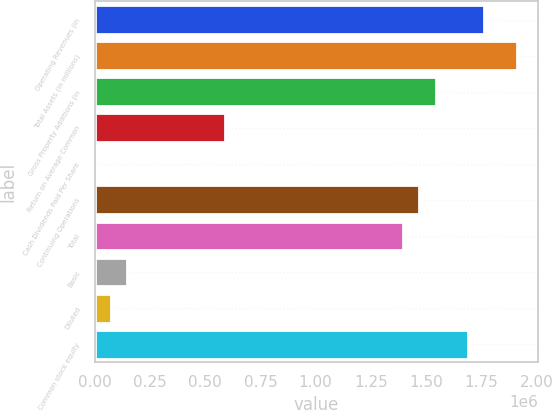Convert chart to OTSL. <chart><loc_0><loc_0><loc_500><loc_500><bar_chart><fcel>Operating Revenues (in<fcel>Total Assets (in millions)<fcel>Gross Property Additions (in<fcel>Return on Average Common<fcel>Cash Dividends Paid Per Share<fcel>Continuing Operations<fcel>Total<fcel>Basic<fcel>Diluted<fcel>Common stock equity<nl><fcel>1.76359e+06<fcel>1.91055e+06<fcel>1.54314e+06<fcel>587863<fcel>1.39<fcel>1.46966e+06<fcel>1.39617e+06<fcel>146967<fcel>73484.1<fcel>1.6901e+06<nl></chart> 